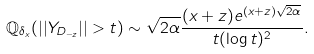Convert formula to latex. <formula><loc_0><loc_0><loc_500><loc_500>\mathbb { Q } _ { \delta _ { x } } ( | | Y _ { D _ { - z } } | | > t ) \sim \sqrt { 2 \alpha } \frac { ( x + z ) e ^ { ( x + z ) \sqrt { 2 \alpha } } } { t ( \log t ) ^ { 2 } } .</formula> 